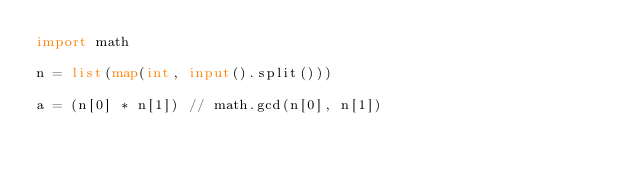<code> <loc_0><loc_0><loc_500><loc_500><_Python_>import math

n = list(map(int, input().split()))

a = (n[0] * n[1]) // math.gcd(n[0], n[1])</code> 